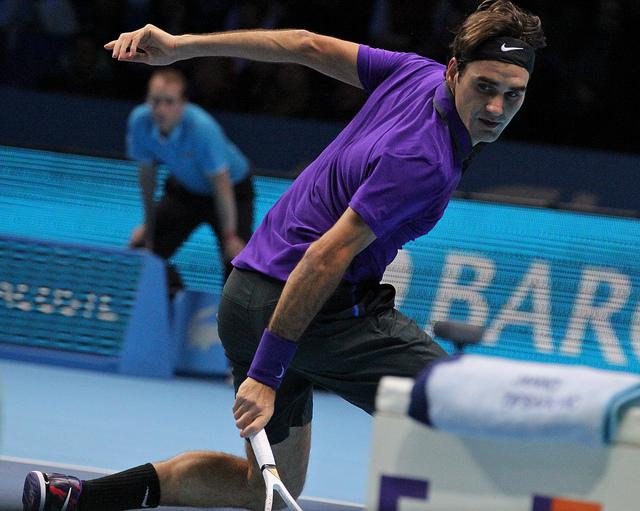Whose picture is this?
Be succinct. Photographer. What is the man planning on doing?
Quick response, please. Hitting ball. Is Mercedes Benz sponsoring this event?
Quick response, please. No. What is he wearing on his head?
Write a very short answer. Headband. What does the headband do?
Answer briefly. Keep sweat out of his face. What color shirt is he wearing?
Quick response, please. Purple. What color is  his shirt?
Concise answer only. Purple. 